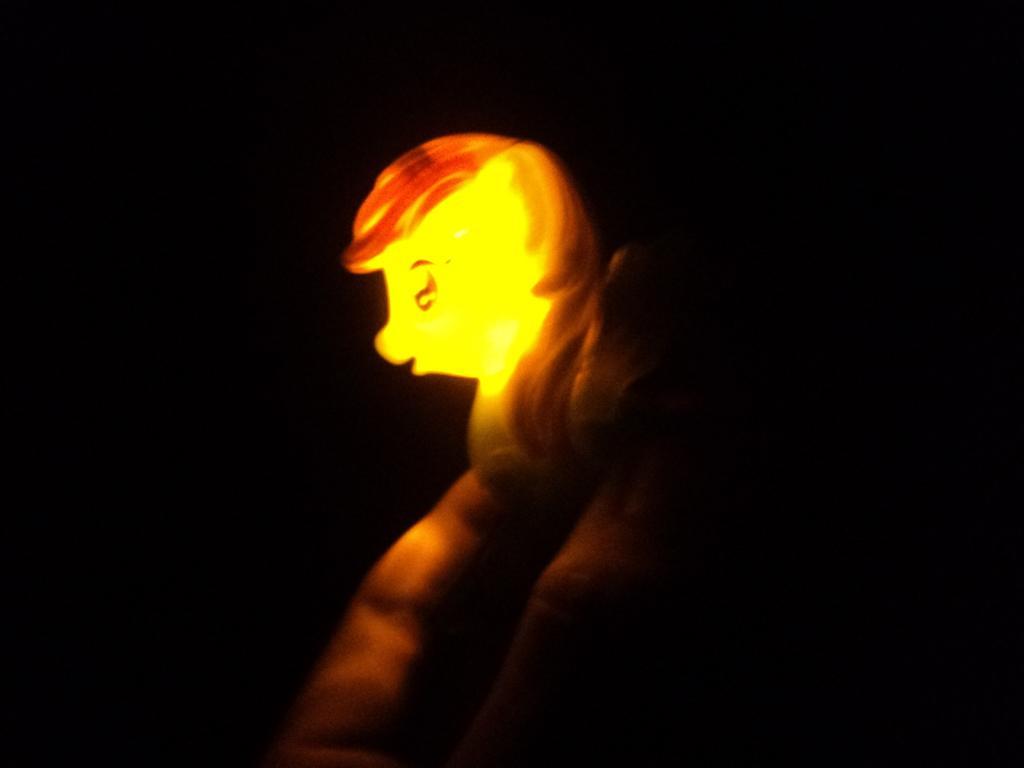Please provide a concise description of this image. In this image there is one person who is holding some toy, from that boy some light is coming. 